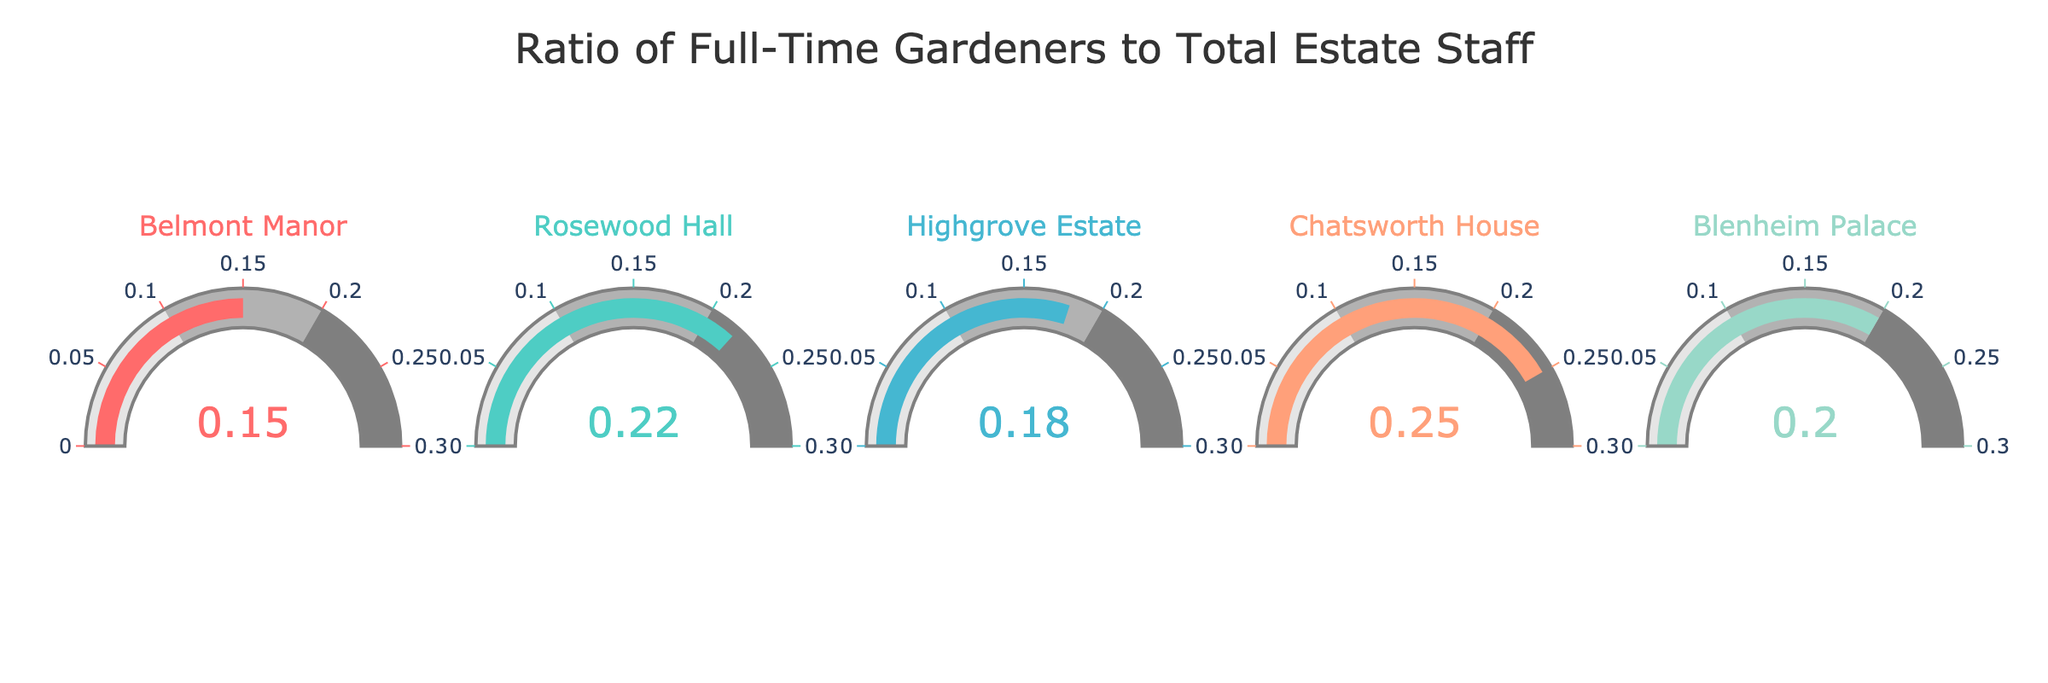What's the title of the figure? The title is generally located at the top of the figure. It gives an overview of what the figure is about. In this case, the title is clearly displayed at the top.
Answer: Ratio of Full-Time Gardeners to Total Estate Staff How many estates are represented in the figure? Count the number of individual gauges presented in the figure, where each gauge corresponds to one estate.
Answer: 5 Which estate has the highest ratio of full-time gardeners? Examine the numbers displayed on each gauge and find the highest value. Chatsworth House has the highest value among all estates.
Answer: Chatsworth House What's the ratio of full-time gardeners for Rosewood Hall? Locate the gauge for Rosewood Hall and read the value displayed on it.
Answer: 0.22 What's the combined ratio of full-time gardeners for Belmont Manor and Highgrove Estate? Add the ratios for Belmont Manor and Highgrove Estate together. Belmont Manor (0.15) + Highgrove Estate (0.18) = 0.33.
Answer: 0.33 How does the ratio of gardeners for Blenheim Palace compare to Belmont Manor? Compare the ratio values for Blenheim Palace (0.20) and Belmont Manor (0.15). Blenheim Palace has a higher ratio.
Answer: Blenheim Palace has a higher ratio Which estate has the lowest ratio of full-time gardeners? Look for the gauge with the smallest value. Belmont Manor has the smallest ratio among the estates.
Answer: Belmont Manor Are there any estates with a ratio of full-time gardeners higher than 0.20? Identify which gauges have values greater than 0.20. Chatsworth House (0.25) and Rosewood Hall (0.22) both have ratios higher than 0.20.
Answer: Yes, Chatsworth House and Rosewood Hall What's the difference in the ratio of full-time gardeners between Chatsworth House and Blenheim Palace? Subtract the ratio of Blenheim Palace from that of Chatsworth House: 0.25 - 0.20 = 0.05.
Answer: 0.05 What is the median ratio of full-time gardeners for the five estates? Sort the ratios and find the middle value. The sorted ratios are 0.15, 0.18, 0.20, 0.22, 0.25. The middle value is 0.20.
Answer: 0.20 